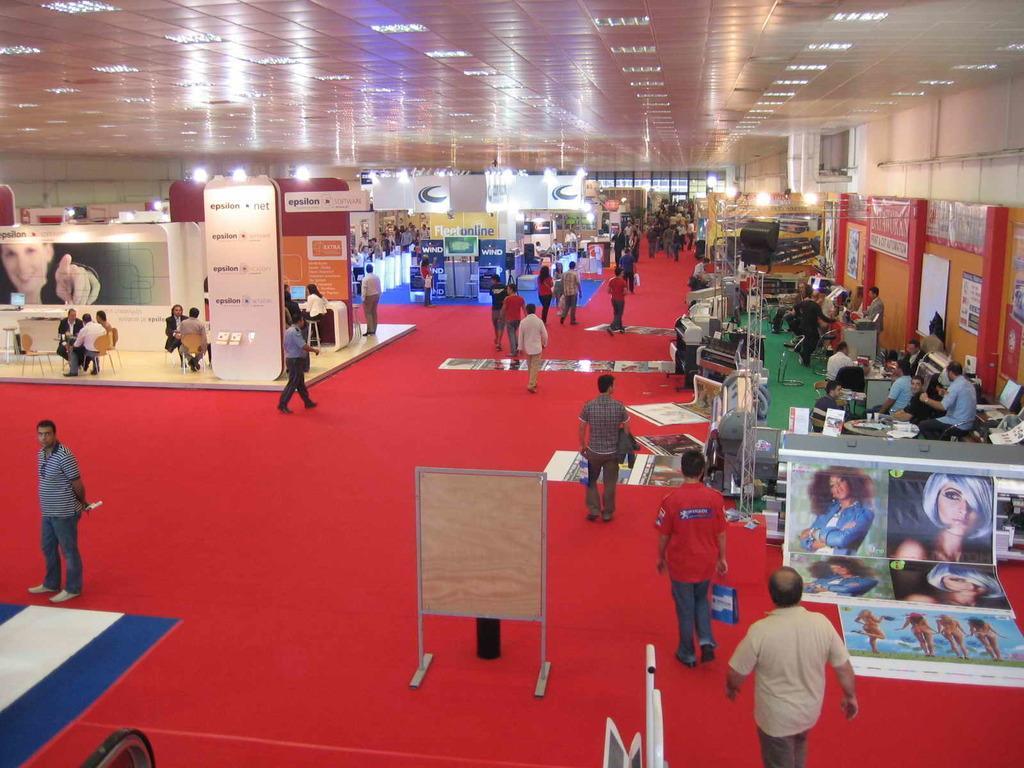How would you summarize this image in a sentence or two? In this image there are many stalls. There are many people in the image. At the bottom of the image there is carpet. At the top of the image there is roof. 